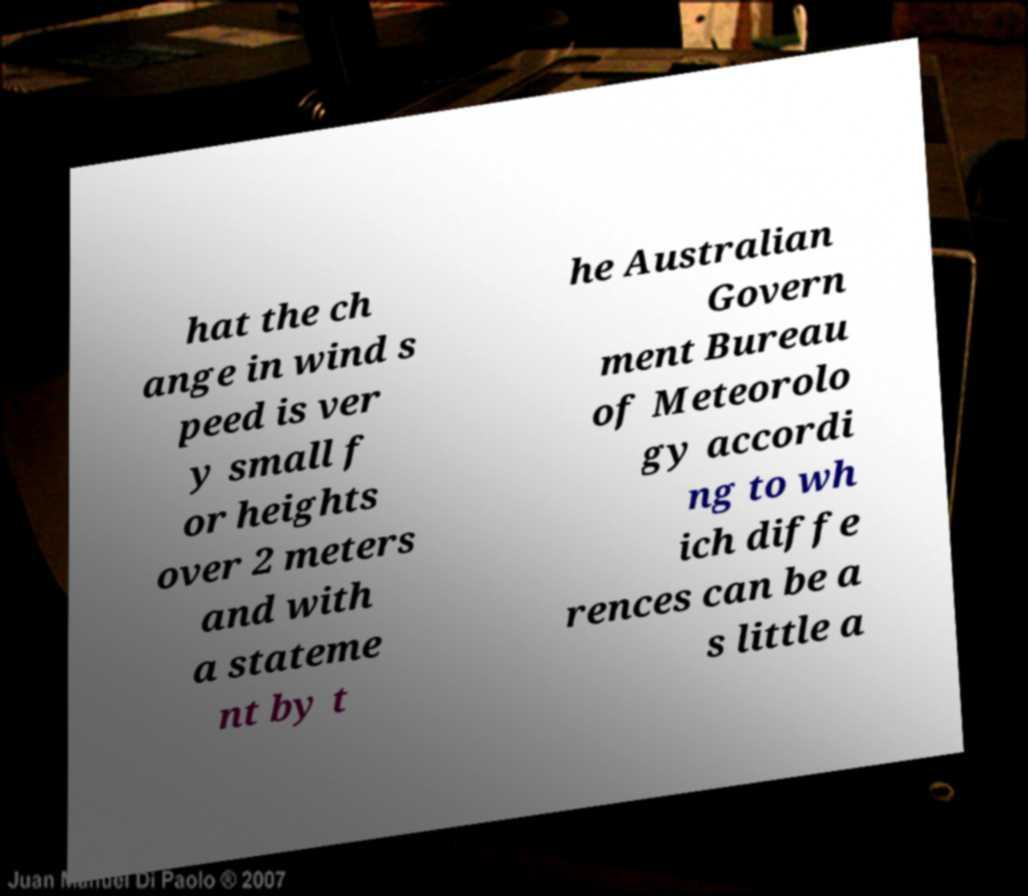Please read and relay the text visible in this image. What does it say? hat the ch ange in wind s peed is ver y small f or heights over 2 meters and with a stateme nt by t he Australian Govern ment Bureau of Meteorolo gy accordi ng to wh ich diffe rences can be a s little a 